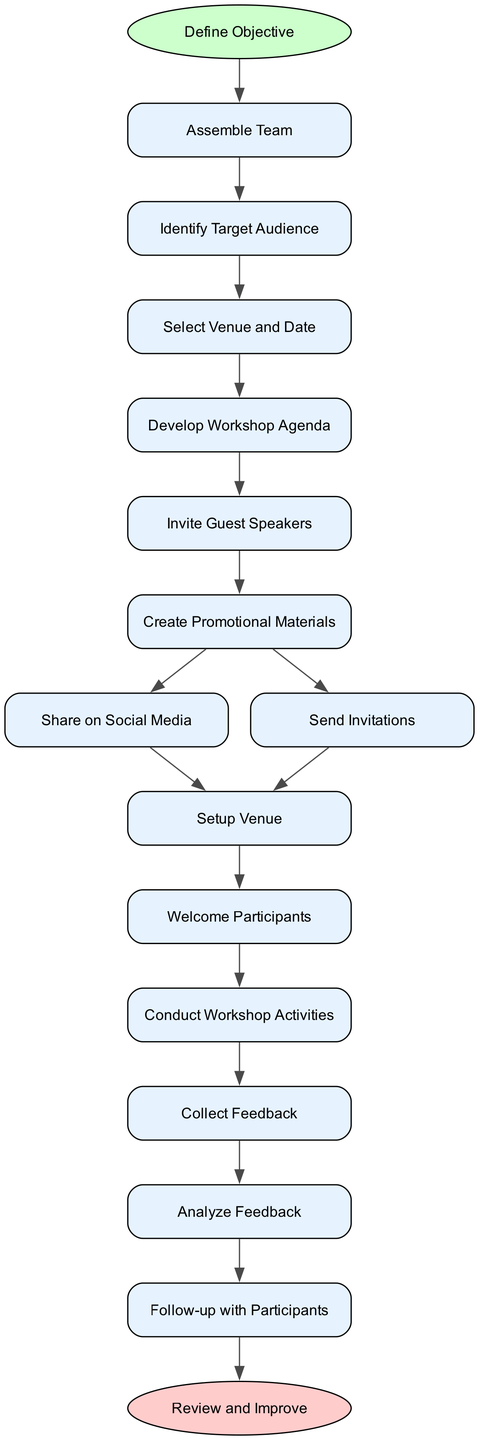What is the starting node of the diagram? The starting node is identified as "Define Objective." It is marked as the initial step in the process, indicated by its type being 'start' and its shape being an ellipse.
Answer: Define Objective How many action nodes are present in the diagram? To determine the number of action nodes, I can count all the nodes with the type 'action.' There are multiple nodes such as "Assemble Team," "Identify Target Audience," "Select Venue and Date," etc. By counting these, the total comes to ten action nodes.
Answer: 10 Which node comes after "Send Invitations"? To find the node that follows "Send Invitations," I check the directed flow from this node. The next connected node based on the diagram’s flow is "Setup Venue."
Answer: Setup Venue What is the final step in the activity described by the diagram? The final step is indicated as a node with the type 'end,' which in this case is "Review and Improve." This signifies the end of the workflow and the completion of the activity.
Answer: Review and Improve How many nodes are connected to "Create Promotional Materials"? Looking at the directed flows originating from "Create Promotional Materials," there are two outgoing connections—one leading to "Share on Social Media" and one leading to "Send Invitations." Thus, two nodes are connected to it.
Answer: 2 What are the first two steps in the process? The first two steps can be traced from the starting node "Define Objective." The subsequent step is "Assemble Team," followed by "Identify Target Audience." Therefore, the first two steps are these two nodes.
Answer: Assemble Team, Identify Target Audience Which action follows "Conduct Workshop Activities"? To find the action that follows "Conduct Workshop Activities," I follow the flow from this node. The next node connected to it is "Collect Feedback," indicating it comes after the activities of the workshop.
Answer: Collect Feedback What is the purpose of the "Analyze Feedback" node? The "Analyze Feedback" node serves the purpose of evaluating the feedback collected after the workshop, which is crucial for assessing the effectiveness and areas of improvement for the event.
Answer: Evaluate feedback How does "Invite Guest Speakers" connect to the overall process? "Invite Guest Speakers" is a crucial action in the planning phase, directly leading from "Develop Workshop Agenda" before the promotion steps. This placement indicates its role in shaping the content and engagement of the workshop.
Answer: Shapes content and engagement 